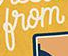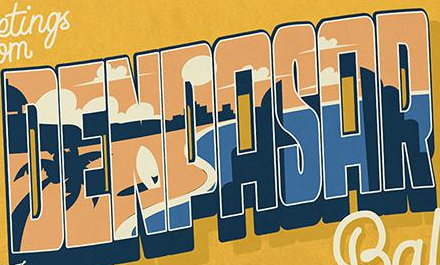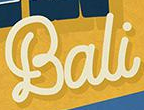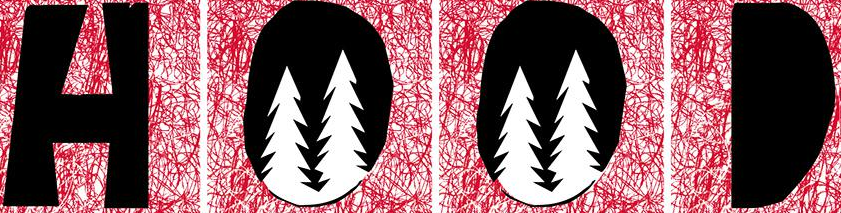What text appears in these images from left to right, separated by a semicolon? from; DENPASAR; Bali; HOOD 